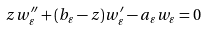Convert formula to latex. <formula><loc_0><loc_0><loc_500><loc_500>z w _ { \varepsilon } ^ { \prime \prime } + ( b _ { \varepsilon } - z ) w _ { \varepsilon } ^ { \prime } - a _ { \varepsilon } w _ { \varepsilon } = 0</formula> 